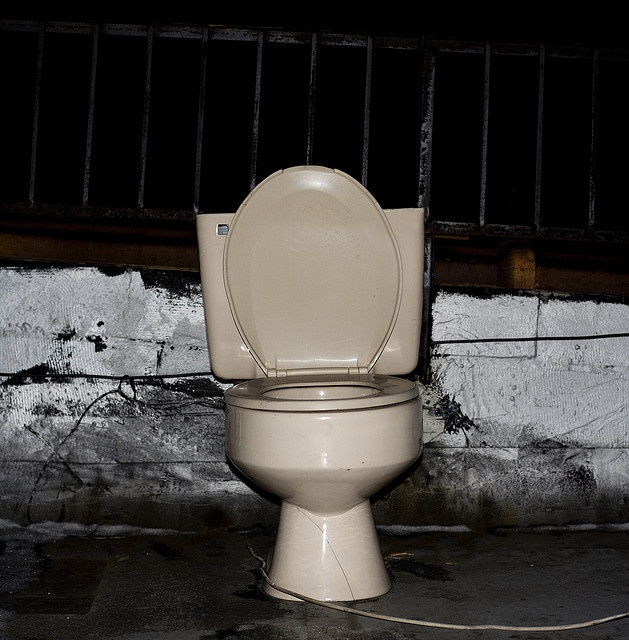Describe the objects in this image and their specific colors. I can see a toilet in black, darkgray, and gray tones in this image. 